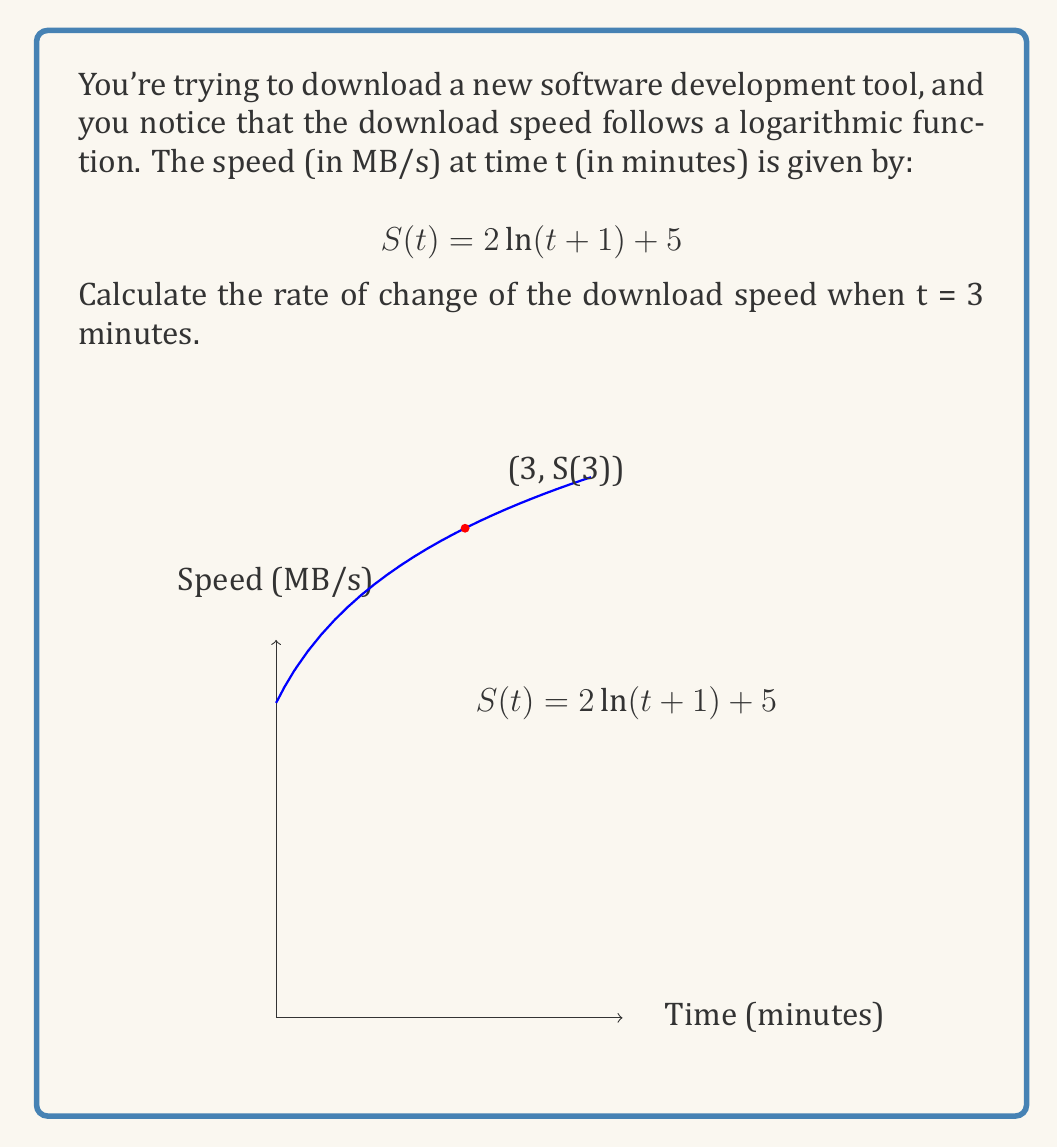Solve this math problem. Let's approach this step-by-step:

1) The rate of change is given by the derivative of the function. So, we need to find $S'(t)$.

2) To differentiate $S(t) = 2 \ln(t+1) + 5$, we use the chain rule:

   $$ S'(t) = 2 \cdot \frac{d}{dt}[\ln(t+1)] + \frac{d}{dt}[5] $$

3) The derivative of $\ln(x)$ is $\frac{1}{x}$, and the derivative of a constant is 0:

   $$ S'(t) = 2 \cdot \frac{1}{t+1} \cdot \frac{d}{dt}[t+1] + 0 $$

4) Simplify:

   $$ S'(t) = \frac{2}{t+1} $$

5) Now, we need to find $S'(3)$. We substitute t = 3 into our derivative function:

   $$ S'(3) = \frac{2}{3+1} = \frac{2}{4} = 0.5 $$

Therefore, the rate of change of the download speed at t = 3 minutes is 0.5 MB/s per minute.
Answer: 0.5 MB/s per minute 